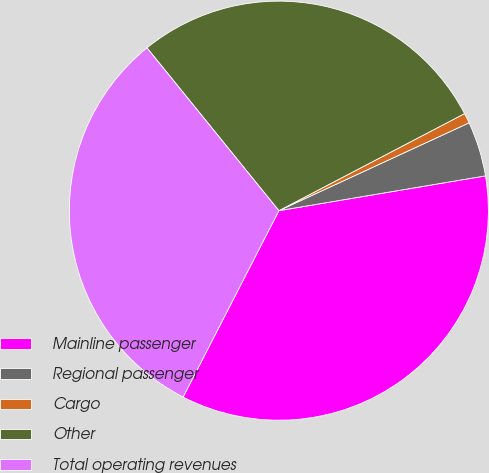Convert chart. <chart><loc_0><loc_0><loc_500><loc_500><pie_chart><fcel>Mainline passenger<fcel>Regional passenger<fcel>Cargo<fcel>Other<fcel>Total operating revenues<nl><fcel>35.21%<fcel>4.23%<fcel>0.78%<fcel>28.17%<fcel>31.61%<nl></chart> 